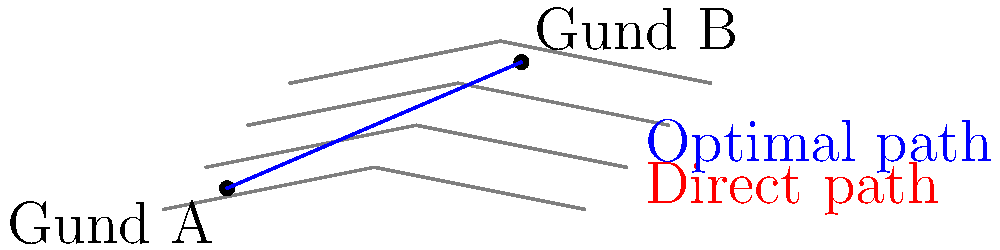As the leader of the Kîkan tribe, you need to plan the safest route between two villages, Gund A and Gund B, on a topographic map of your tribal lands. The direct path crosses steep terrain, while a longer route follows gentler slopes. Given that each contour line represents a 20-meter increase in elevation, what is the approximate difference in elevation gained between the direct path and the optimal path? To solve this problem, we need to analyze the elevation changes along both paths:

1. Direct path (red dashed line):
   - Starts at about 10m elevation
   - Crosses 3 contour lines
   - Ends at about 70m elevation
   - Total elevation gain: $70m - 10m = 60m$

2. Optimal path (blue solid line):
   - Starts at about 10m elevation
   - Follows the contour lines more closely
   - Crosses about 1.5 contour lines
   - Ends at about 70m elevation
   - Total elevation gain: $70m - 10m = 60m$

3. Calculate the difference:
   - Elevation gain difference = Direct path gain - Optimal path gain
   - $60m - 60m = 0m$

Although the optimal path is longer, it doesn't result in any additional elevation gain. The benefit of this path is that it follows gentler slopes, making it safer and easier to traverse, which is crucial for the well-being of the tribe members traveling between the villages.
Answer: $0$ meters 